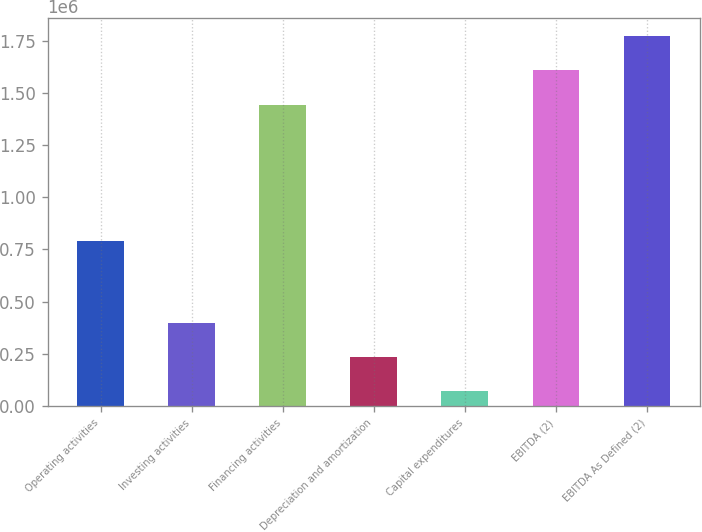Convert chart. <chart><loc_0><loc_0><loc_500><loc_500><bar_chart><fcel>Operating activities<fcel>Investing activities<fcel>Financing activities<fcel>Depreciation and amortization<fcel>Capital expenditures<fcel>EBITDA (2)<fcel>EBITDA As Defined (2)<nl><fcel>788733<fcel>398923<fcel>1.44368e+06<fcel>234968<fcel>71013<fcel>1.60764e+06<fcel>1.77159e+06<nl></chart> 